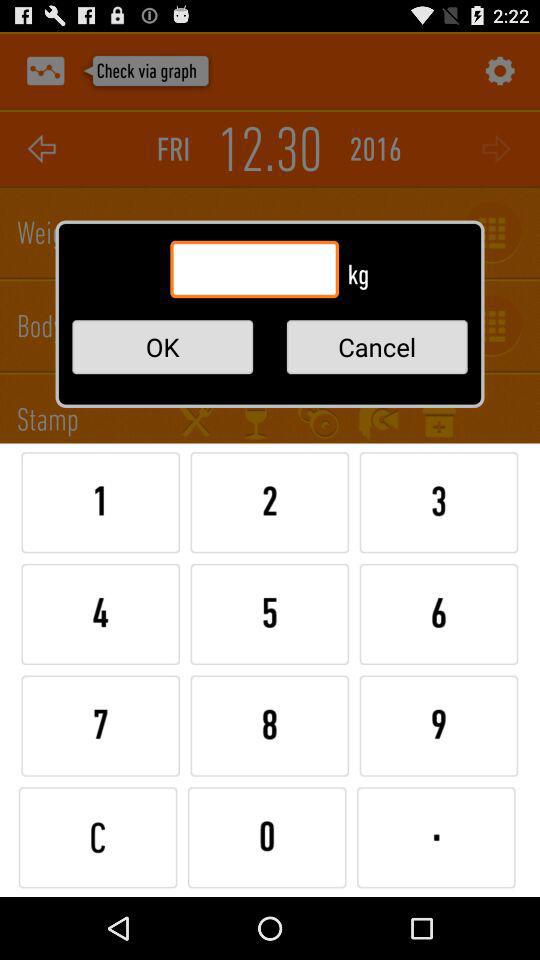What day was selected? The selected date was Friday, December 30, 2016. 